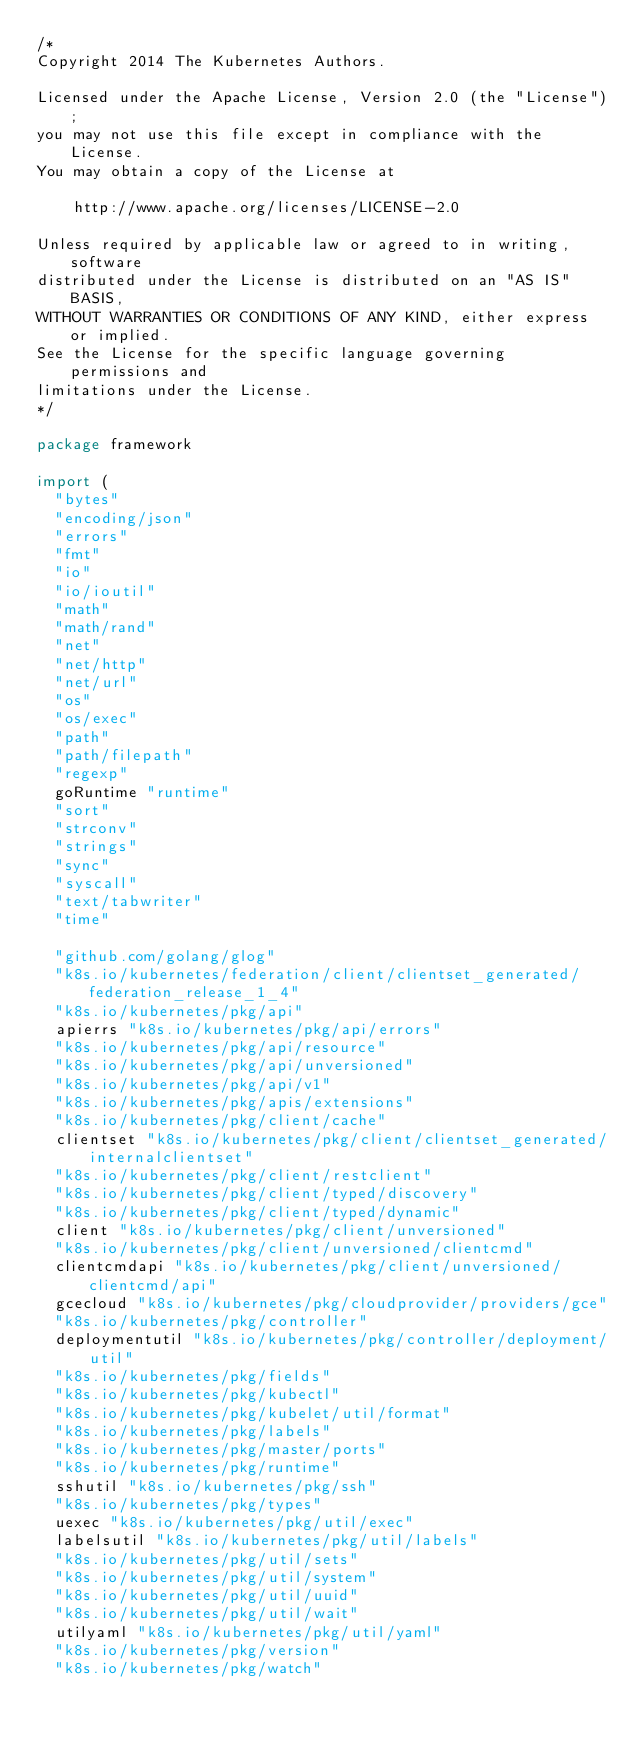<code> <loc_0><loc_0><loc_500><loc_500><_Go_>/*
Copyright 2014 The Kubernetes Authors.

Licensed under the Apache License, Version 2.0 (the "License");
you may not use this file except in compliance with the License.
You may obtain a copy of the License at

    http://www.apache.org/licenses/LICENSE-2.0

Unless required by applicable law or agreed to in writing, software
distributed under the License is distributed on an "AS IS" BASIS,
WITHOUT WARRANTIES OR CONDITIONS OF ANY KIND, either express or implied.
See the License for the specific language governing permissions and
limitations under the License.
*/

package framework

import (
	"bytes"
	"encoding/json"
	"errors"
	"fmt"
	"io"
	"io/ioutil"
	"math"
	"math/rand"
	"net"
	"net/http"
	"net/url"
	"os"
	"os/exec"
	"path"
	"path/filepath"
	"regexp"
	goRuntime "runtime"
	"sort"
	"strconv"
	"strings"
	"sync"
	"syscall"
	"text/tabwriter"
	"time"

	"github.com/golang/glog"
	"k8s.io/kubernetes/federation/client/clientset_generated/federation_release_1_4"
	"k8s.io/kubernetes/pkg/api"
	apierrs "k8s.io/kubernetes/pkg/api/errors"
	"k8s.io/kubernetes/pkg/api/resource"
	"k8s.io/kubernetes/pkg/api/unversioned"
	"k8s.io/kubernetes/pkg/api/v1"
	"k8s.io/kubernetes/pkg/apis/extensions"
	"k8s.io/kubernetes/pkg/client/cache"
	clientset "k8s.io/kubernetes/pkg/client/clientset_generated/internalclientset"
	"k8s.io/kubernetes/pkg/client/restclient"
	"k8s.io/kubernetes/pkg/client/typed/discovery"
	"k8s.io/kubernetes/pkg/client/typed/dynamic"
	client "k8s.io/kubernetes/pkg/client/unversioned"
	"k8s.io/kubernetes/pkg/client/unversioned/clientcmd"
	clientcmdapi "k8s.io/kubernetes/pkg/client/unversioned/clientcmd/api"
	gcecloud "k8s.io/kubernetes/pkg/cloudprovider/providers/gce"
	"k8s.io/kubernetes/pkg/controller"
	deploymentutil "k8s.io/kubernetes/pkg/controller/deployment/util"
	"k8s.io/kubernetes/pkg/fields"
	"k8s.io/kubernetes/pkg/kubectl"
	"k8s.io/kubernetes/pkg/kubelet/util/format"
	"k8s.io/kubernetes/pkg/labels"
	"k8s.io/kubernetes/pkg/master/ports"
	"k8s.io/kubernetes/pkg/runtime"
	sshutil "k8s.io/kubernetes/pkg/ssh"
	"k8s.io/kubernetes/pkg/types"
	uexec "k8s.io/kubernetes/pkg/util/exec"
	labelsutil "k8s.io/kubernetes/pkg/util/labels"
	"k8s.io/kubernetes/pkg/util/sets"
	"k8s.io/kubernetes/pkg/util/system"
	"k8s.io/kubernetes/pkg/util/uuid"
	"k8s.io/kubernetes/pkg/util/wait"
	utilyaml "k8s.io/kubernetes/pkg/util/yaml"
	"k8s.io/kubernetes/pkg/version"
	"k8s.io/kubernetes/pkg/watch"
</code> 